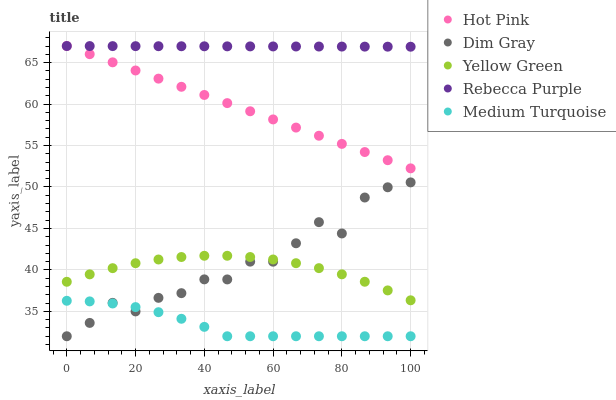Does Medium Turquoise have the minimum area under the curve?
Answer yes or no. Yes. Does Rebecca Purple have the maximum area under the curve?
Answer yes or no. Yes. Does Hot Pink have the minimum area under the curve?
Answer yes or no. No. Does Hot Pink have the maximum area under the curve?
Answer yes or no. No. Is Hot Pink the smoothest?
Answer yes or no. Yes. Is Dim Gray the roughest?
Answer yes or no. Yes. Is Yellow Green the smoothest?
Answer yes or no. No. Is Yellow Green the roughest?
Answer yes or no. No. Does Dim Gray have the lowest value?
Answer yes or no. Yes. Does Hot Pink have the lowest value?
Answer yes or no. No. Does Rebecca Purple have the highest value?
Answer yes or no. Yes. Does Yellow Green have the highest value?
Answer yes or no. No. Is Yellow Green less than Hot Pink?
Answer yes or no. Yes. Is Hot Pink greater than Medium Turquoise?
Answer yes or no. Yes. Does Rebecca Purple intersect Hot Pink?
Answer yes or no. Yes. Is Rebecca Purple less than Hot Pink?
Answer yes or no. No. Is Rebecca Purple greater than Hot Pink?
Answer yes or no. No. Does Yellow Green intersect Hot Pink?
Answer yes or no. No. 